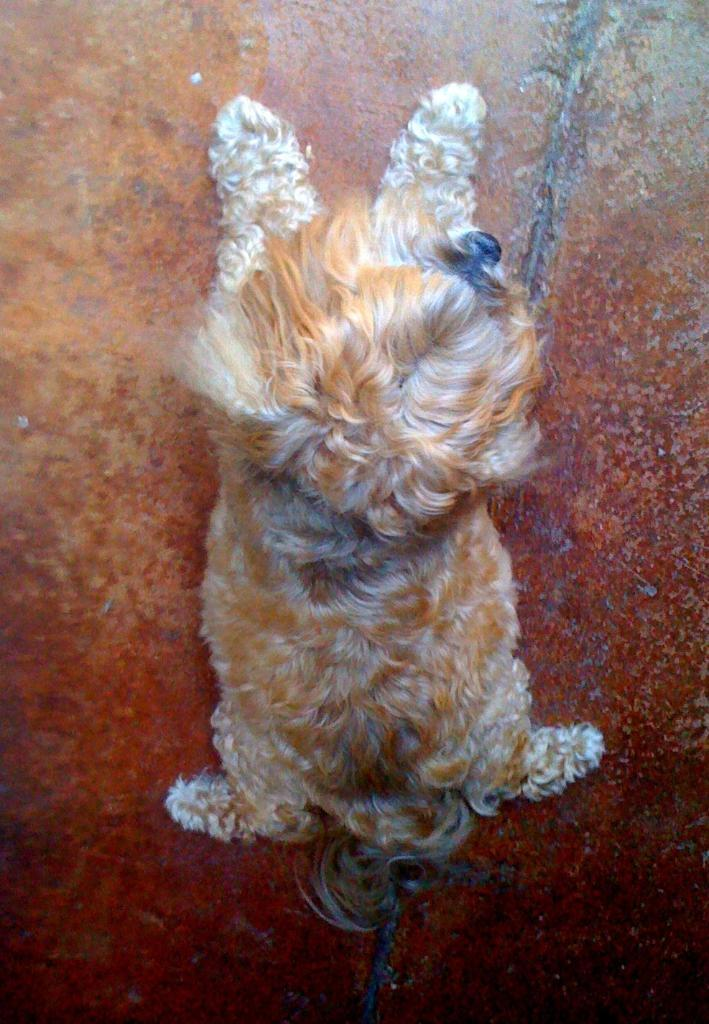What animal is present in the image? There is a dog in the image. Where is the dog located in the image? The dog is sitting on the floor. What type of sea creature can be seen interacting with the dog in the image? There is no sea creature present in the image; it only features a dog sitting on the floor. What type of war equipment is visible in the image? There is no war equipment present in the image; it only features a dog sitting on the floor. 